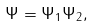<formula> <loc_0><loc_0><loc_500><loc_500>\Psi = \Psi _ { 1 } \Psi _ { 2 } ,</formula> 